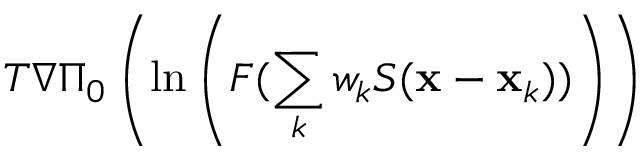<formula> <loc_0><loc_0><loc_500><loc_500>T \nabla \Pi _ { 0 } \left ( \ln \left ( F ( \sum _ { k } w _ { k } S ( { \mathbf x } - { \mathbf x } _ { k } ) ) \right ) \right )</formula> 